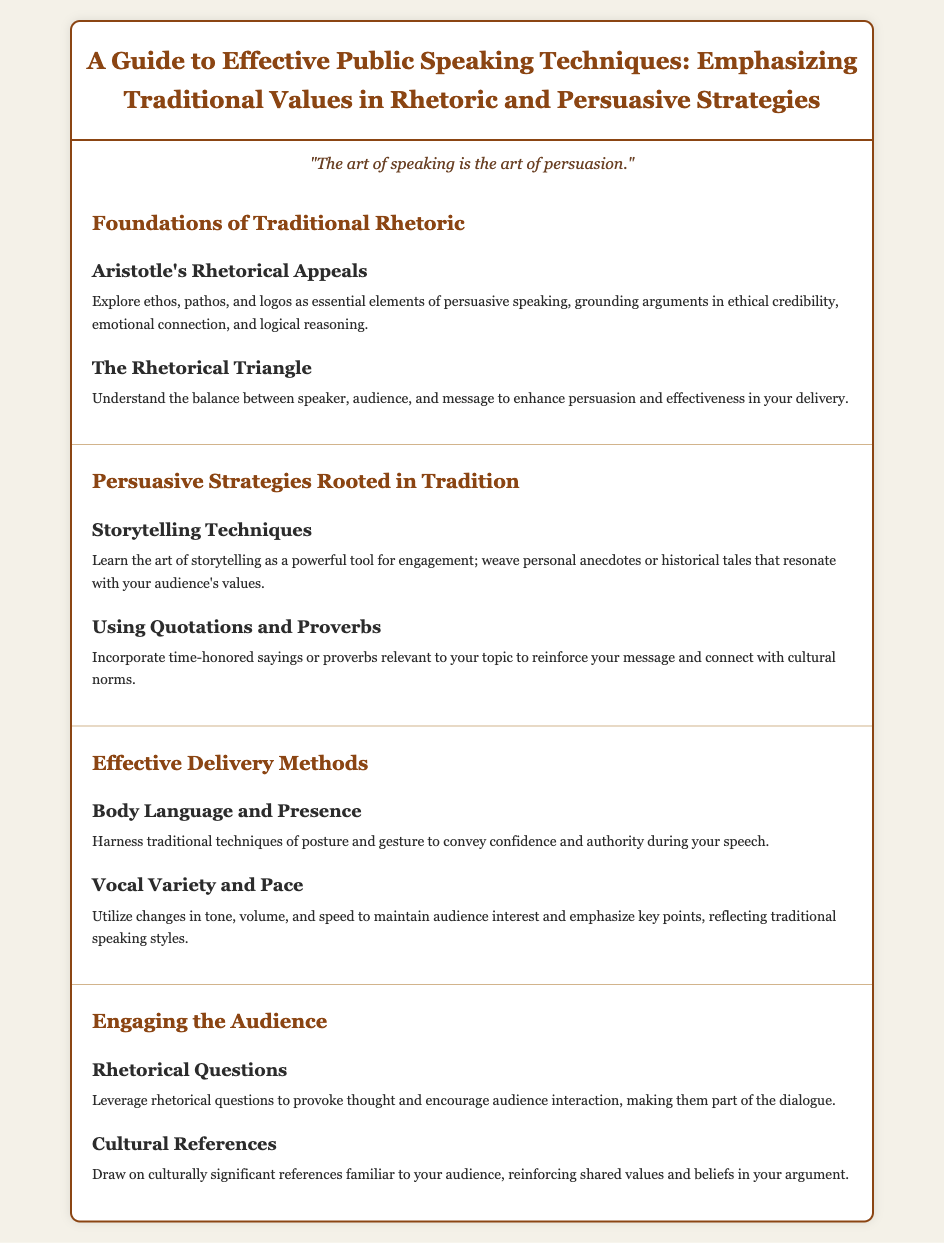What are the three rhetorical appeals mentioned? The document states that Aristotle's Rhetorical Appeals include ethos, pathos, and logos as essential elements of persuasive speaking.
Answer: ethos, pathos, and logos What does the Rhetorical Triangle balance? The document describes the Rhetorical Triangle as balancing the speaker, audience, and message to enhance persuasion.
Answer: speaker, audience, and message What technique is highlighted as a powerful tool for engagement? The document emphasizes storytelling techniques as a powerful tool for engagement in speeches.
Answer: storytelling techniques What should be utilized for maintaining audience interest according to the document? The document suggests utilizing vocal variety and pace to maintain audience interest and emphasize key points.
Answer: vocal variety and pace What is advised to incorporate to reinforce your message? The document advises incorporating time-honored sayings or proverbs relevant to the topic to reinforce the message.
Answer: time-honored sayings or proverbs What method is important for conveying confidence? The document states that traditional techniques of body language and presence are important for conveying confidence and authority during a speech.
Answer: body language and presence 